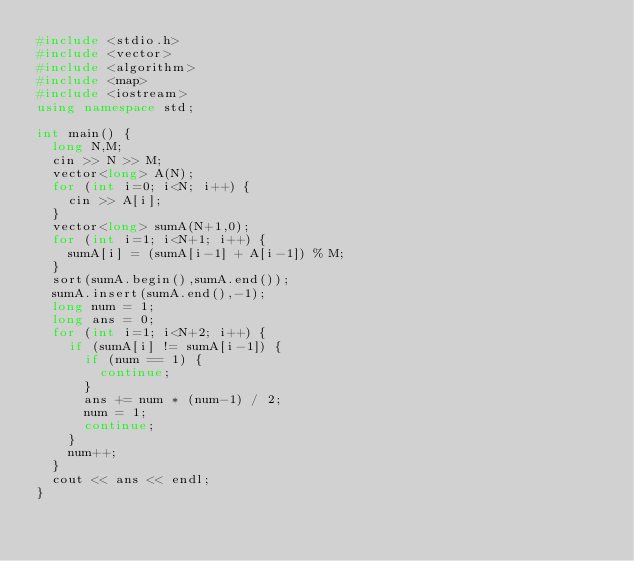Convert code to text. <code><loc_0><loc_0><loc_500><loc_500><_C++_>#include <stdio.h>
#include <vector>
#include <algorithm>
#include <map>
#include <iostream>
using namespace std;

int main() {
  long N,M;
  cin >> N >> M;
  vector<long> A(N);
  for (int i=0; i<N; i++) {
    cin >> A[i];
  }
  vector<long> sumA(N+1,0);
  for (int i=1; i<N+1; i++) {
    sumA[i] = (sumA[i-1] + A[i-1]) % M;
  }
  sort(sumA.begin(),sumA.end());
  sumA.insert(sumA.end(),-1);
  long num = 1;
  long ans = 0;
  for (int i=1; i<N+2; i++) {
    if (sumA[i] != sumA[i-1]) {
      if (num == 1) {
        continue;
      }
      ans += num * (num-1) / 2;
      num = 1;
      continue;
    }
    num++;
  }
  cout << ans << endl;
}</code> 